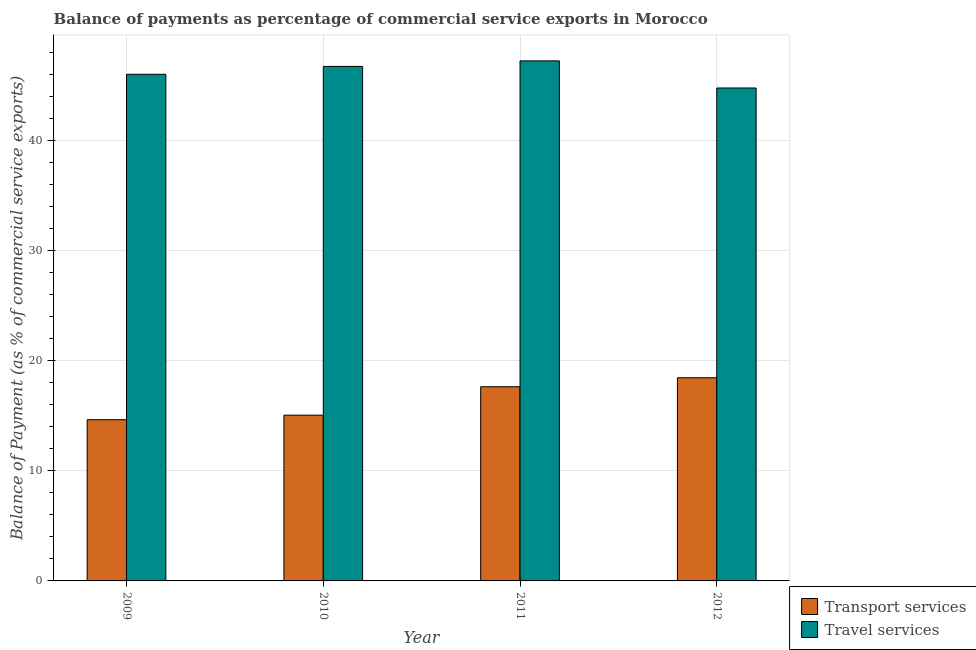How many bars are there on the 2nd tick from the right?
Provide a short and direct response. 2. What is the label of the 4th group of bars from the left?
Offer a very short reply. 2012. In how many cases, is the number of bars for a given year not equal to the number of legend labels?
Offer a terse response. 0. What is the balance of payments of travel services in 2010?
Offer a very short reply. 46.77. Across all years, what is the maximum balance of payments of travel services?
Provide a succinct answer. 47.27. Across all years, what is the minimum balance of payments of transport services?
Give a very brief answer. 14.66. In which year was the balance of payments of travel services minimum?
Offer a terse response. 2012. What is the total balance of payments of transport services in the graph?
Offer a terse response. 65.84. What is the difference between the balance of payments of travel services in 2009 and that in 2011?
Give a very brief answer. -1.22. What is the difference between the balance of payments of transport services in 2012 and the balance of payments of travel services in 2010?
Your response must be concise. 3.4. What is the average balance of payments of transport services per year?
Provide a succinct answer. 16.46. In the year 2009, what is the difference between the balance of payments of travel services and balance of payments of transport services?
Offer a very short reply. 0. In how many years, is the balance of payments of transport services greater than 12 %?
Give a very brief answer. 4. What is the ratio of the balance of payments of transport services in 2009 to that in 2010?
Give a very brief answer. 0.97. What is the difference between the highest and the second highest balance of payments of transport services?
Make the answer very short. 0.82. What is the difference between the highest and the lowest balance of payments of transport services?
Your response must be concise. 3.81. What does the 1st bar from the left in 2012 represents?
Your answer should be compact. Transport services. What does the 2nd bar from the right in 2009 represents?
Your response must be concise. Transport services. How many bars are there?
Provide a short and direct response. 8. What is the difference between two consecutive major ticks on the Y-axis?
Provide a succinct answer. 10. Does the graph contain any zero values?
Your answer should be compact. No. What is the title of the graph?
Provide a short and direct response. Balance of payments as percentage of commercial service exports in Morocco. What is the label or title of the X-axis?
Provide a short and direct response. Year. What is the label or title of the Y-axis?
Your response must be concise. Balance of Payment (as % of commercial service exports). What is the Balance of Payment (as % of commercial service exports) in Transport services in 2009?
Keep it short and to the point. 14.66. What is the Balance of Payment (as % of commercial service exports) of Travel services in 2009?
Your response must be concise. 46.05. What is the Balance of Payment (as % of commercial service exports) in Transport services in 2010?
Ensure brevity in your answer.  15.07. What is the Balance of Payment (as % of commercial service exports) in Travel services in 2010?
Ensure brevity in your answer.  46.77. What is the Balance of Payment (as % of commercial service exports) in Transport services in 2011?
Your answer should be very brief. 17.65. What is the Balance of Payment (as % of commercial service exports) of Travel services in 2011?
Keep it short and to the point. 47.27. What is the Balance of Payment (as % of commercial service exports) of Transport services in 2012?
Your answer should be compact. 18.47. What is the Balance of Payment (as % of commercial service exports) in Travel services in 2012?
Your response must be concise. 44.81. Across all years, what is the maximum Balance of Payment (as % of commercial service exports) of Transport services?
Offer a terse response. 18.47. Across all years, what is the maximum Balance of Payment (as % of commercial service exports) of Travel services?
Provide a short and direct response. 47.27. Across all years, what is the minimum Balance of Payment (as % of commercial service exports) of Transport services?
Offer a very short reply. 14.66. Across all years, what is the minimum Balance of Payment (as % of commercial service exports) in Travel services?
Provide a succinct answer. 44.81. What is the total Balance of Payment (as % of commercial service exports) of Transport services in the graph?
Offer a very short reply. 65.84. What is the total Balance of Payment (as % of commercial service exports) in Travel services in the graph?
Make the answer very short. 184.9. What is the difference between the Balance of Payment (as % of commercial service exports) of Transport services in 2009 and that in 2010?
Ensure brevity in your answer.  -0.41. What is the difference between the Balance of Payment (as % of commercial service exports) in Travel services in 2009 and that in 2010?
Your answer should be compact. -0.72. What is the difference between the Balance of Payment (as % of commercial service exports) in Transport services in 2009 and that in 2011?
Make the answer very short. -3. What is the difference between the Balance of Payment (as % of commercial service exports) in Travel services in 2009 and that in 2011?
Provide a succinct answer. -1.22. What is the difference between the Balance of Payment (as % of commercial service exports) of Transport services in 2009 and that in 2012?
Offer a terse response. -3.81. What is the difference between the Balance of Payment (as % of commercial service exports) of Travel services in 2009 and that in 2012?
Provide a short and direct response. 1.24. What is the difference between the Balance of Payment (as % of commercial service exports) in Transport services in 2010 and that in 2011?
Give a very brief answer. -2.58. What is the difference between the Balance of Payment (as % of commercial service exports) of Travel services in 2010 and that in 2011?
Your response must be concise. -0.5. What is the difference between the Balance of Payment (as % of commercial service exports) in Transport services in 2010 and that in 2012?
Make the answer very short. -3.4. What is the difference between the Balance of Payment (as % of commercial service exports) of Travel services in 2010 and that in 2012?
Your answer should be very brief. 1.96. What is the difference between the Balance of Payment (as % of commercial service exports) of Transport services in 2011 and that in 2012?
Your answer should be compact. -0.82. What is the difference between the Balance of Payment (as % of commercial service exports) in Travel services in 2011 and that in 2012?
Your answer should be very brief. 2.46. What is the difference between the Balance of Payment (as % of commercial service exports) of Transport services in 2009 and the Balance of Payment (as % of commercial service exports) of Travel services in 2010?
Your answer should be compact. -32.11. What is the difference between the Balance of Payment (as % of commercial service exports) of Transport services in 2009 and the Balance of Payment (as % of commercial service exports) of Travel services in 2011?
Provide a short and direct response. -32.62. What is the difference between the Balance of Payment (as % of commercial service exports) in Transport services in 2009 and the Balance of Payment (as % of commercial service exports) in Travel services in 2012?
Keep it short and to the point. -30.15. What is the difference between the Balance of Payment (as % of commercial service exports) of Transport services in 2010 and the Balance of Payment (as % of commercial service exports) of Travel services in 2011?
Make the answer very short. -32.21. What is the difference between the Balance of Payment (as % of commercial service exports) in Transport services in 2010 and the Balance of Payment (as % of commercial service exports) in Travel services in 2012?
Ensure brevity in your answer.  -29.74. What is the difference between the Balance of Payment (as % of commercial service exports) of Transport services in 2011 and the Balance of Payment (as % of commercial service exports) of Travel services in 2012?
Offer a terse response. -27.16. What is the average Balance of Payment (as % of commercial service exports) in Transport services per year?
Your answer should be very brief. 16.46. What is the average Balance of Payment (as % of commercial service exports) in Travel services per year?
Give a very brief answer. 46.23. In the year 2009, what is the difference between the Balance of Payment (as % of commercial service exports) in Transport services and Balance of Payment (as % of commercial service exports) in Travel services?
Offer a terse response. -31.4. In the year 2010, what is the difference between the Balance of Payment (as % of commercial service exports) of Transport services and Balance of Payment (as % of commercial service exports) of Travel services?
Provide a succinct answer. -31.7. In the year 2011, what is the difference between the Balance of Payment (as % of commercial service exports) in Transport services and Balance of Payment (as % of commercial service exports) in Travel services?
Provide a succinct answer. -29.62. In the year 2012, what is the difference between the Balance of Payment (as % of commercial service exports) of Transport services and Balance of Payment (as % of commercial service exports) of Travel services?
Give a very brief answer. -26.34. What is the ratio of the Balance of Payment (as % of commercial service exports) of Transport services in 2009 to that in 2010?
Keep it short and to the point. 0.97. What is the ratio of the Balance of Payment (as % of commercial service exports) of Travel services in 2009 to that in 2010?
Your response must be concise. 0.98. What is the ratio of the Balance of Payment (as % of commercial service exports) of Transport services in 2009 to that in 2011?
Provide a short and direct response. 0.83. What is the ratio of the Balance of Payment (as % of commercial service exports) in Travel services in 2009 to that in 2011?
Your answer should be very brief. 0.97. What is the ratio of the Balance of Payment (as % of commercial service exports) in Transport services in 2009 to that in 2012?
Provide a short and direct response. 0.79. What is the ratio of the Balance of Payment (as % of commercial service exports) in Travel services in 2009 to that in 2012?
Provide a succinct answer. 1.03. What is the ratio of the Balance of Payment (as % of commercial service exports) of Transport services in 2010 to that in 2011?
Offer a very short reply. 0.85. What is the ratio of the Balance of Payment (as % of commercial service exports) in Travel services in 2010 to that in 2011?
Your response must be concise. 0.99. What is the ratio of the Balance of Payment (as % of commercial service exports) in Transport services in 2010 to that in 2012?
Make the answer very short. 0.82. What is the ratio of the Balance of Payment (as % of commercial service exports) of Travel services in 2010 to that in 2012?
Provide a short and direct response. 1.04. What is the ratio of the Balance of Payment (as % of commercial service exports) of Transport services in 2011 to that in 2012?
Provide a short and direct response. 0.96. What is the ratio of the Balance of Payment (as % of commercial service exports) of Travel services in 2011 to that in 2012?
Make the answer very short. 1.05. What is the difference between the highest and the second highest Balance of Payment (as % of commercial service exports) of Transport services?
Your answer should be compact. 0.82. What is the difference between the highest and the second highest Balance of Payment (as % of commercial service exports) of Travel services?
Your response must be concise. 0.5. What is the difference between the highest and the lowest Balance of Payment (as % of commercial service exports) of Transport services?
Give a very brief answer. 3.81. What is the difference between the highest and the lowest Balance of Payment (as % of commercial service exports) in Travel services?
Your response must be concise. 2.46. 